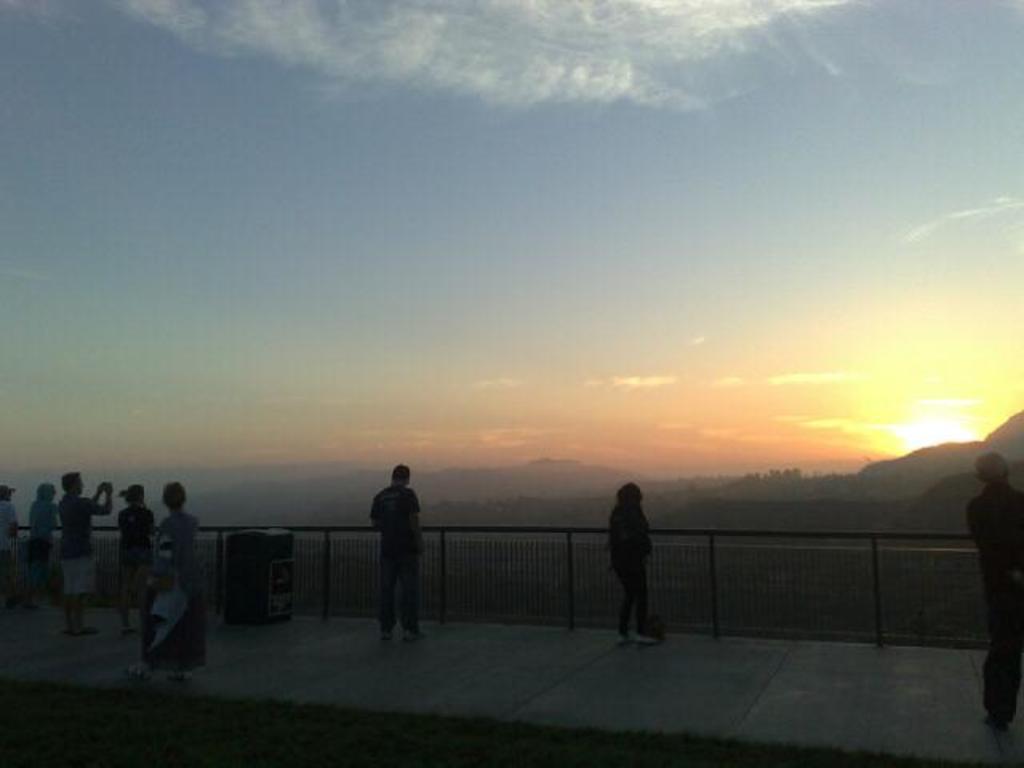Can you describe this image briefly? At the bottom of the image there are few people standing and also there is a bin. In front of them there is a fencing. Behind the fencing there are hills. And at the top of the image there is a sky with sun. 